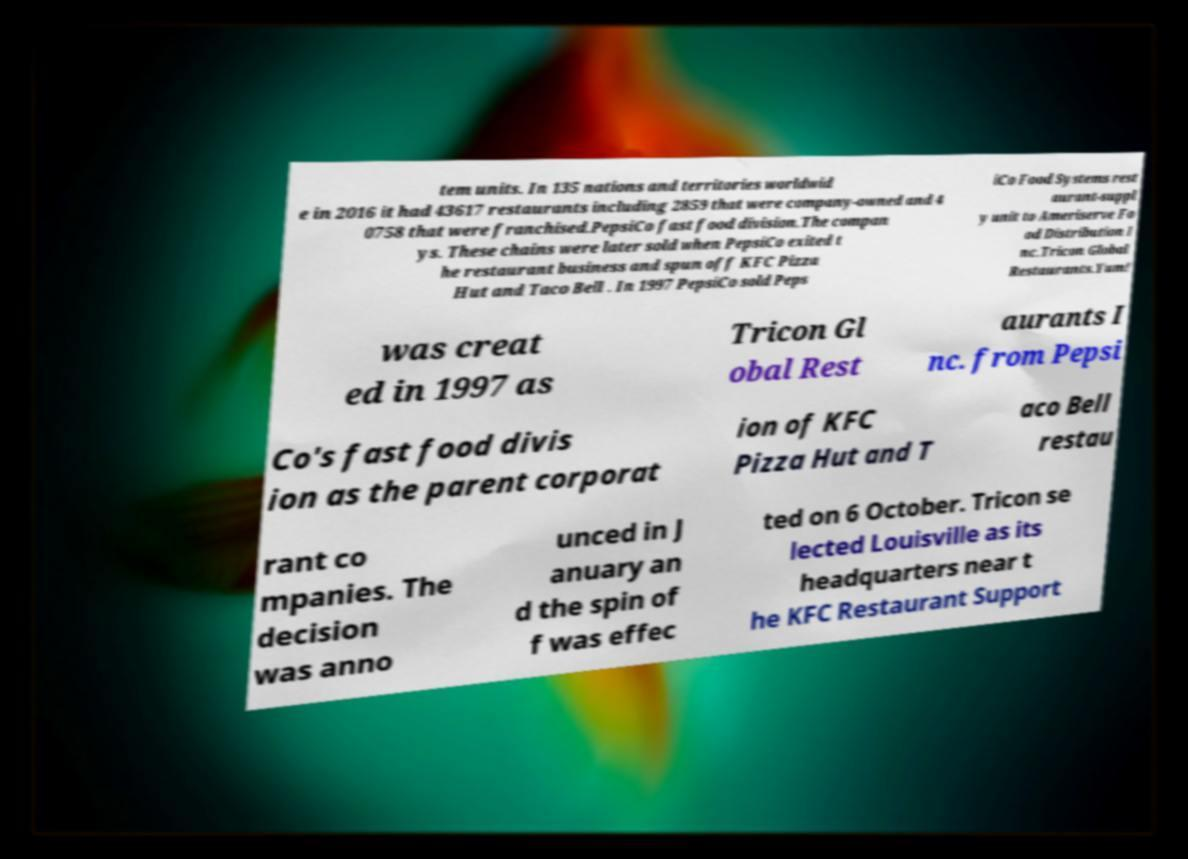Can you accurately transcribe the text from the provided image for me? tem units. In 135 nations and territories worldwid e in 2016 it had 43617 restaurants including 2859 that were company-owned and 4 0758 that were franchised.PepsiCo fast food division.The compan ys. These chains were later sold when PepsiCo exited t he restaurant business and spun off KFC Pizza Hut and Taco Bell . In 1997 PepsiCo sold Peps iCo Food Systems rest aurant-suppl y unit to Ameriserve Fo od Distribution I nc.Tricon Global Restaurants.Yum! was creat ed in 1997 as Tricon Gl obal Rest aurants I nc. from Pepsi Co's fast food divis ion as the parent corporat ion of KFC Pizza Hut and T aco Bell restau rant co mpanies. The decision was anno unced in J anuary an d the spin of f was effec ted on 6 October. Tricon se lected Louisville as its headquarters near t he KFC Restaurant Support 